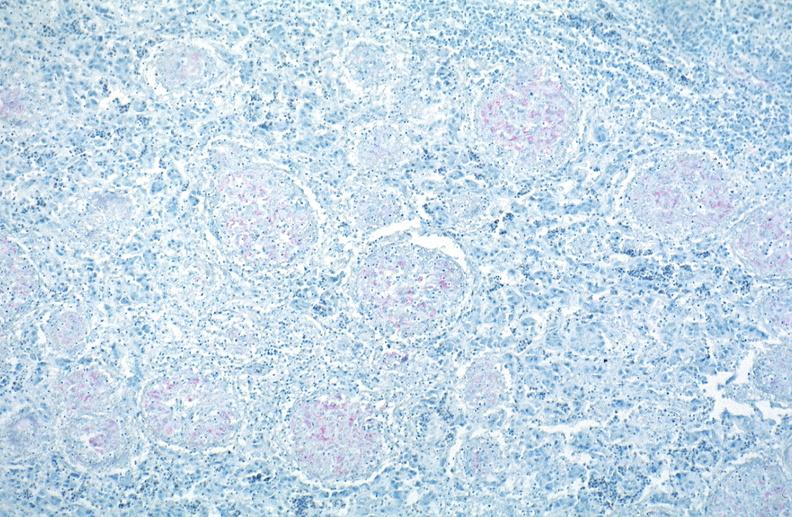does ulcer with candida infection show lung, mycobacterium tuberculosis, acid fast?
Answer the question using a single word or phrase. No 